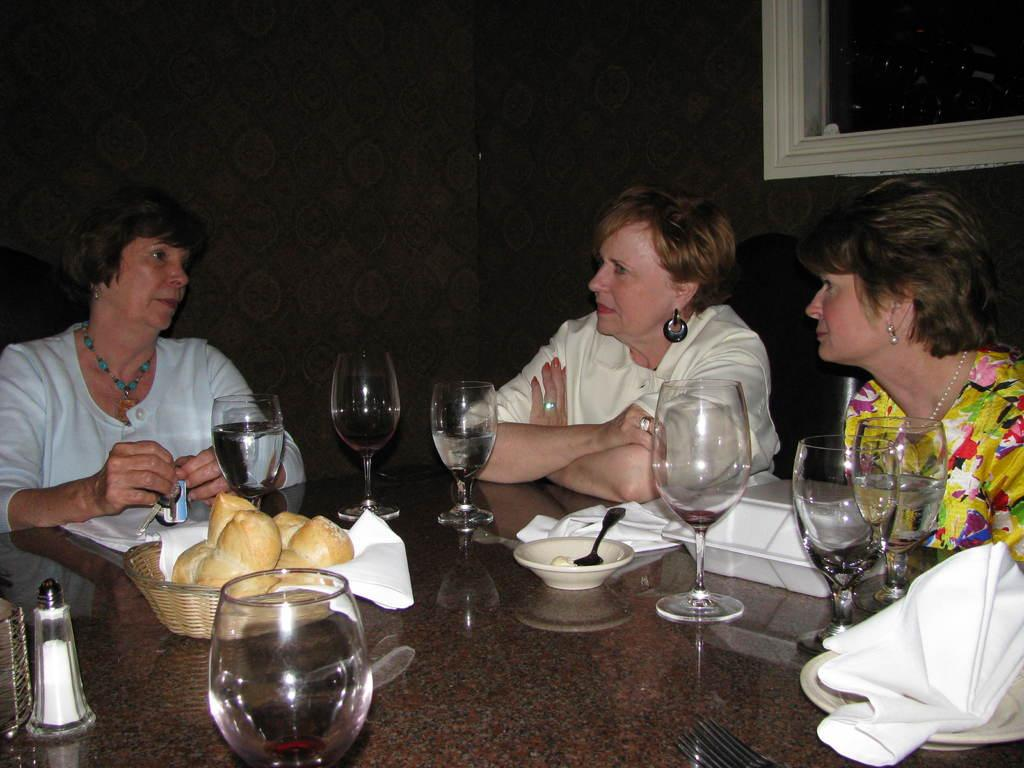How many people are in the image? There are three people in the image. What are the people doing in the image? The people are sitting on chairs. Where are the chairs located in relation to the table? The chairs are in front of a table. What items can be seen on the table? There are glasses, bowls, and tissues on the table. Where is the grandmother sitting in the image? There is no mention of a grandmother in the image, so we cannot determine her location. 